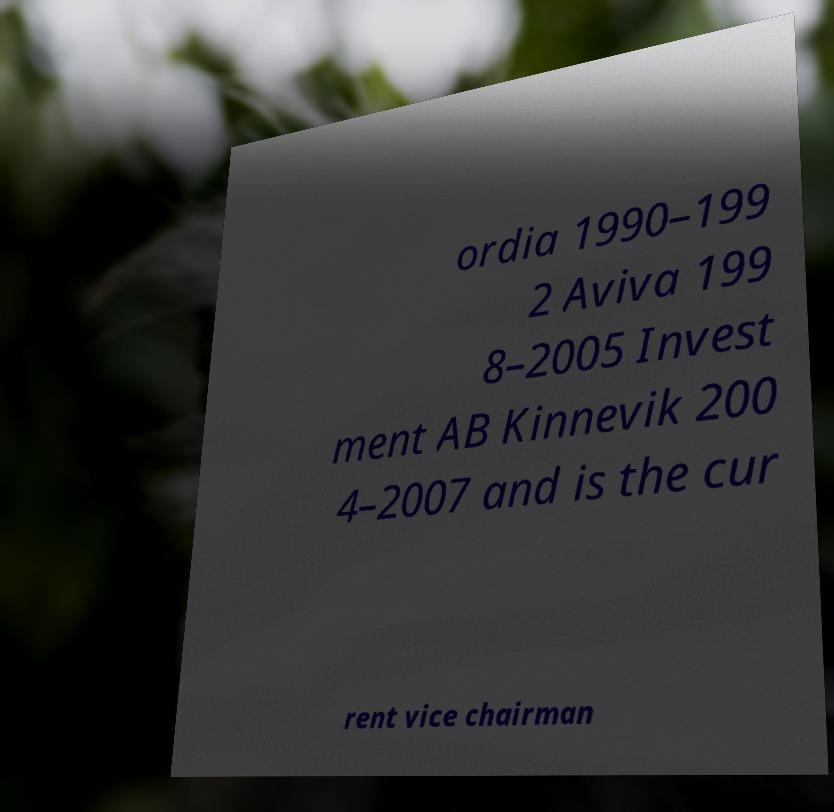Can you accurately transcribe the text from the provided image for me? ordia 1990–199 2 Aviva 199 8–2005 Invest ment AB Kinnevik 200 4–2007 and is the cur rent vice chairman 